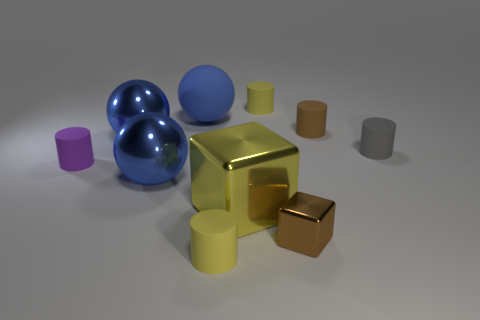What number of other objects are there of the same size as the yellow metallic block?
Ensure brevity in your answer.  3. There is a big rubber thing; is it the same color as the tiny matte cylinder that is behind the blue matte thing?
Your response must be concise. No. Are there fewer yellow rubber objects behind the brown shiny object than yellow objects that are right of the blue matte object?
Make the answer very short. Yes. What is the color of the matte cylinder that is both right of the brown cube and left of the gray thing?
Make the answer very short. Brown. There is a brown metal cube; does it have the same size as the blue shiny object in front of the small purple thing?
Keep it short and to the point. No. The shiny thing that is behind the tiny gray matte cylinder has what shape?
Provide a short and direct response. Sphere. Is the number of large spheres behind the big blue rubber sphere greater than the number of green balls?
Offer a very short reply. No. There is a big blue ball in front of the purple rubber thing that is in front of the gray thing; what number of brown rubber objects are in front of it?
Ensure brevity in your answer.  0. Do the blue thing that is in front of the purple cylinder and the yellow rubber cylinder behind the gray object have the same size?
Offer a terse response. No. What material is the cube that is right of the cylinder that is behind the large blue matte thing made of?
Offer a very short reply. Metal. 